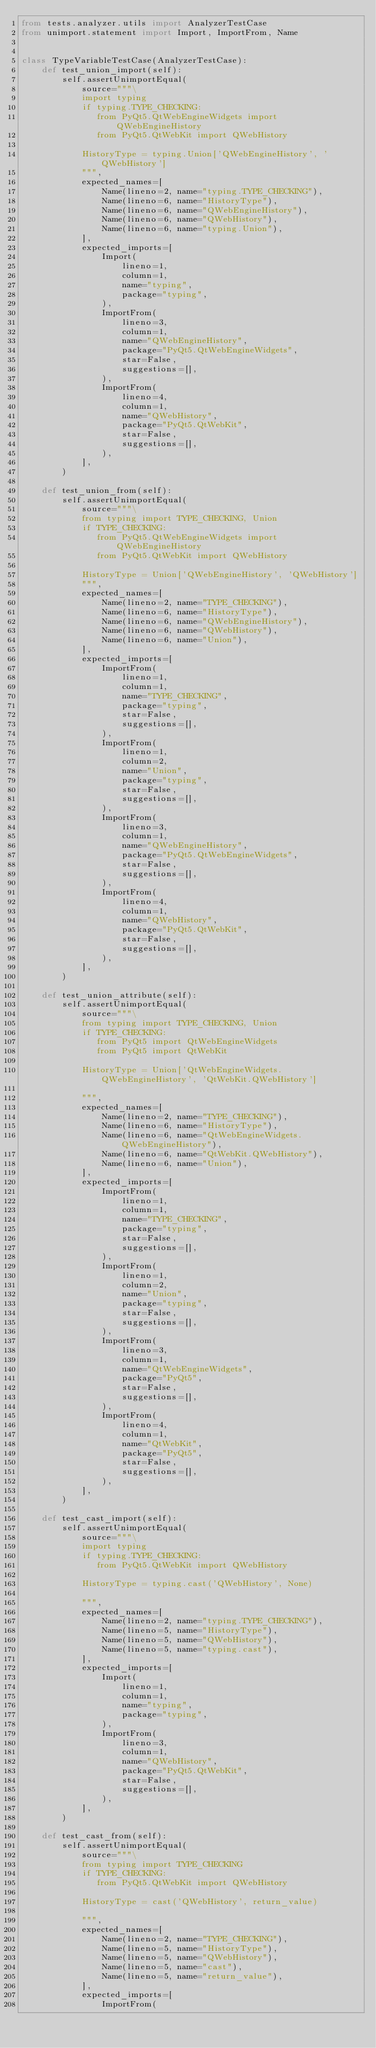Convert code to text. <code><loc_0><loc_0><loc_500><loc_500><_Python_>from tests.analyzer.utils import AnalyzerTestCase
from unimport.statement import Import, ImportFrom, Name


class TypeVariableTestCase(AnalyzerTestCase):
    def test_union_import(self):
        self.assertUnimportEqual(
            source="""\
            import typing
            if typing.TYPE_CHECKING:
               from PyQt5.QtWebEngineWidgets import QWebEngineHistory
               from PyQt5.QtWebKit import QWebHistory

            HistoryType = typing.Union['QWebEngineHistory', 'QWebHistory']
            """,
            expected_names=[
                Name(lineno=2, name="typing.TYPE_CHECKING"),
                Name(lineno=6, name="HistoryType"),
                Name(lineno=6, name="QWebEngineHistory"),
                Name(lineno=6, name="QWebHistory"),
                Name(lineno=6, name="typing.Union"),
            ],
            expected_imports=[
                Import(
                    lineno=1,
                    column=1,
                    name="typing",
                    package="typing",
                ),
                ImportFrom(
                    lineno=3,
                    column=1,
                    name="QWebEngineHistory",
                    package="PyQt5.QtWebEngineWidgets",
                    star=False,
                    suggestions=[],
                ),
                ImportFrom(
                    lineno=4,
                    column=1,
                    name="QWebHistory",
                    package="PyQt5.QtWebKit",
                    star=False,
                    suggestions=[],
                ),
            ],
        )

    def test_union_from(self):
        self.assertUnimportEqual(
            source="""\
            from typing import TYPE_CHECKING, Union
            if TYPE_CHECKING:
               from PyQt5.QtWebEngineWidgets import QWebEngineHistory
               from PyQt5.QtWebKit import QWebHistory

            HistoryType = Union['QWebEngineHistory', 'QWebHistory']
            """,
            expected_names=[
                Name(lineno=2, name="TYPE_CHECKING"),
                Name(lineno=6, name="HistoryType"),
                Name(lineno=6, name="QWebEngineHistory"),
                Name(lineno=6, name="QWebHistory"),
                Name(lineno=6, name="Union"),
            ],
            expected_imports=[
                ImportFrom(
                    lineno=1,
                    column=1,
                    name="TYPE_CHECKING",
                    package="typing",
                    star=False,
                    suggestions=[],
                ),
                ImportFrom(
                    lineno=1,
                    column=2,
                    name="Union",
                    package="typing",
                    star=False,
                    suggestions=[],
                ),
                ImportFrom(
                    lineno=3,
                    column=1,
                    name="QWebEngineHistory",
                    package="PyQt5.QtWebEngineWidgets",
                    star=False,
                    suggestions=[],
                ),
                ImportFrom(
                    lineno=4,
                    column=1,
                    name="QWebHistory",
                    package="PyQt5.QtWebKit",
                    star=False,
                    suggestions=[],
                ),
            ],
        )

    def test_union_attribute(self):
        self.assertUnimportEqual(
            source="""\
            from typing import TYPE_CHECKING, Union
            if TYPE_CHECKING:
               from PyQt5 import QtWebEngineWidgets
               from PyQt5 import QtWebKit

            HistoryType = Union['QtWebEngineWidgets.QWebEngineHistory', 'QtWebKit.QWebHistory']

            """,
            expected_names=[
                Name(lineno=2, name="TYPE_CHECKING"),
                Name(lineno=6, name="HistoryType"),
                Name(lineno=6, name="QtWebEngineWidgets.QWebEngineHistory"),
                Name(lineno=6, name="QtWebKit.QWebHistory"),
                Name(lineno=6, name="Union"),
            ],
            expected_imports=[
                ImportFrom(
                    lineno=1,
                    column=1,
                    name="TYPE_CHECKING",
                    package="typing",
                    star=False,
                    suggestions=[],
                ),
                ImportFrom(
                    lineno=1,
                    column=2,
                    name="Union",
                    package="typing",
                    star=False,
                    suggestions=[],
                ),
                ImportFrom(
                    lineno=3,
                    column=1,
                    name="QtWebEngineWidgets",
                    package="PyQt5",
                    star=False,
                    suggestions=[],
                ),
                ImportFrom(
                    lineno=4,
                    column=1,
                    name="QtWebKit",
                    package="PyQt5",
                    star=False,
                    suggestions=[],
                ),
            ],
        )

    def test_cast_import(self):
        self.assertUnimportEqual(
            source="""\
            import typing
            if typing.TYPE_CHECKING:
               from PyQt5.QtWebKit import QWebHistory

            HistoryType = typing.cast('QWebHistory', None)

            """,
            expected_names=[
                Name(lineno=2, name="typing.TYPE_CHECKING"),
                Name(lineno=5, name="HistoryType"),
                Name(lineno=5, name="QWebHistory"),
                Name(lineno=5, name="typing.cast"),
            ],
            expected_imports=[
                Import(
                    lineno=1,
                    column=1,
                    name="typing",
                    package="typing",
                ),
                ImportFrom(
                    lineno=3,
                    column=1,
                    name="QWebHistory",
                    package="PyQt5.QtWebKit",
                    star=False,
                    suggestions=[],
                ),
            ],
        )

    def test_cast_from(self):
        self.assertUnimportEqual(
            source="""\
            from typing import TYPE_CHECKING
            if TYPE_CHECKING:
               from PyQt5.QtWebKit import QWebHistory

            HistoryType = cast('QWebHistory', return_value)

            """,
            expected_names=[
                Name(lineno=2, name="TYPE_CHECKING"),
                Name(lineno=5, name="HistoryType"),
                Name(lineno=5, name="QWebHistory"),
                Name(lineno=5, name="cast"),
                Name(lineno=5, name="return_value"),
            ],
            expected_imports=[
                ImportFrom(</code> 